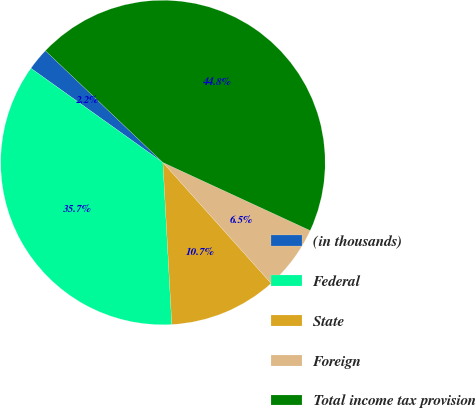Convert chart to OTSL. <chart><loc_0><loc_0><loc_500><loc_500><pie_chart><fcel>(in thousands)<fcel>Federal<fcel>State<fcel>Foreign<fcel>Total income tax provision<nl><fcel>2.24%<fcel>35.74%<fcel>10.75%<fcel>6.49%<fcel>44.79%<nl></chart> 